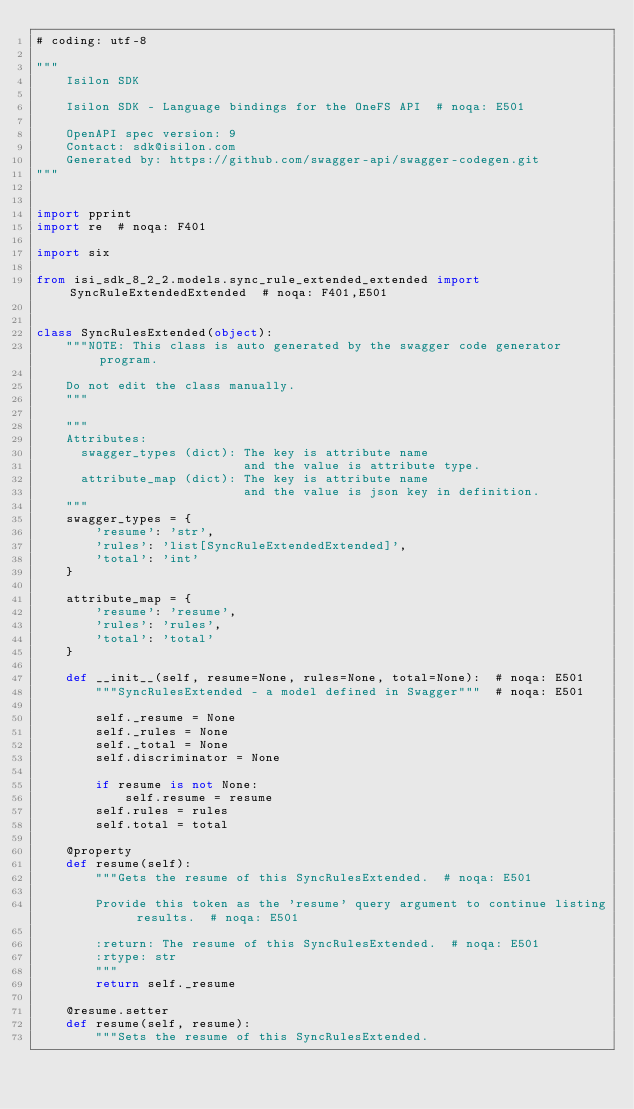Convert code to text. <code><loc_0><loc_0><loc_500><loc_500><_Python_># coding: utf-8

"""
    Isilon SDK

    Isilon SDK - Language bindings for the OneFS API  # noqa: E501

    OpenAPI spec version: 9
    Contact: sdk@isilon.com
    Generated by: https://github.com/swagger-api/swagger-codegen.git
"""


import pprint
import re  # noqa: F401

import six

from isi_sdk_8_2_2.models.sync_rule_extended_extended import SyncRuleExtendedExtended  # noqa: F401,E501


class SyncRulesExtended(object):
    """NOTE: This class is auto generated by the swagger code generator program.

    Do not edit the class manually.
    """

    """
    Attributes:
      swagger_types (dict): The key is attribute name
                            and the value is attribute type.
      attribute_map (dict): The key is attribute name
                            and the value is json key in definition.
    """
    swagger_types = {
        'resume': 'str',
        'rules': 'list[SyncRuleExtendedExtended]',
        'total': 'int'
    }

    attribute_map = {
        'resume': 'resume',
        'rules': 'rules',
        'total': 'total'
    }

    def __init__(self, resume=None, rules=None, total=None):  # noqa: E501
        """SyncRulesExtended - a model defined in Swagger"""  # noqa: E501

        self._resume = None
        self._rules = None
        self._total = None
        self.discriminator = None

        if resume is not None:
            self.resume = resume
        self.rules = rules
        self.total = total

    @property
    def resume(self):
        """Gets the resume of this SyncRulesExtended.  # noqa: E501

        Provide this token as the 'resume' query argument to continue listing results.  # noqa: E501

        :return: The resume of this SyncRulesExtended.  # noqa: E501
        :rtype: str
        """
        return self._resume

    @resume.setter
    def resume(self, resume):
        """Sets the resume of this SyncRulesExtended.
</code> 